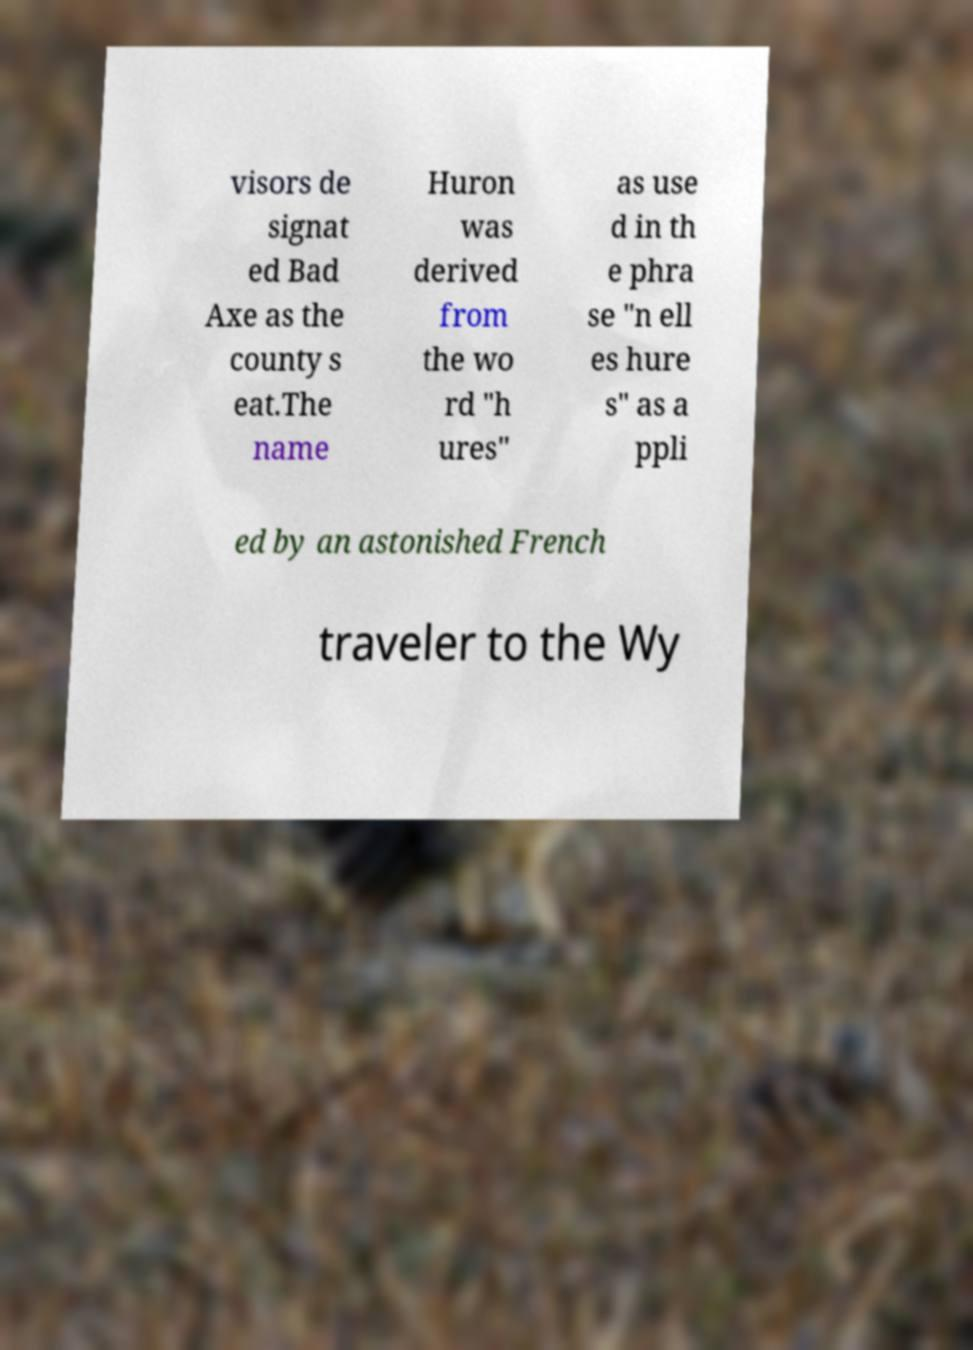Please identify and transcribe the text found in this image. visors de signat ed Bad Axe as the county s eat.The name Huron was derived from the wo rd "h ures" as use d in th e phra se "n ell es hure s" as a ppli ed by an astonished French traveler to the Wy 